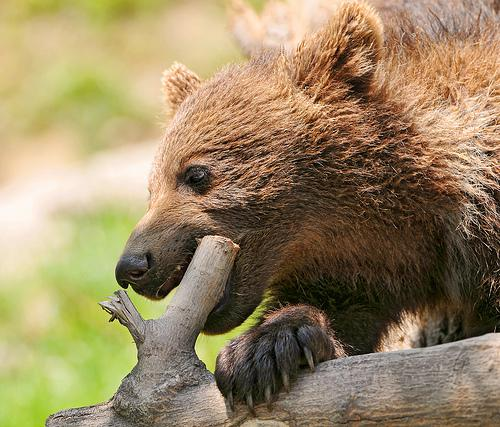Question: what type of animal is shown?
Choices:
A. A wolf.
B. A tiger.
C. A bear.
D. A deer.
Answer with the letter. Answer: C Question: where is the bear?
Choices:
A. In the woods.
B. On log.
C. Under houses.
D. On the hill.
Answer with the letter. Answer: B Question: how many logs can be seen?
Choices:
A. Two.
B. Four.
C. Three.
D. One.
Answer with the letter. Answer: D 